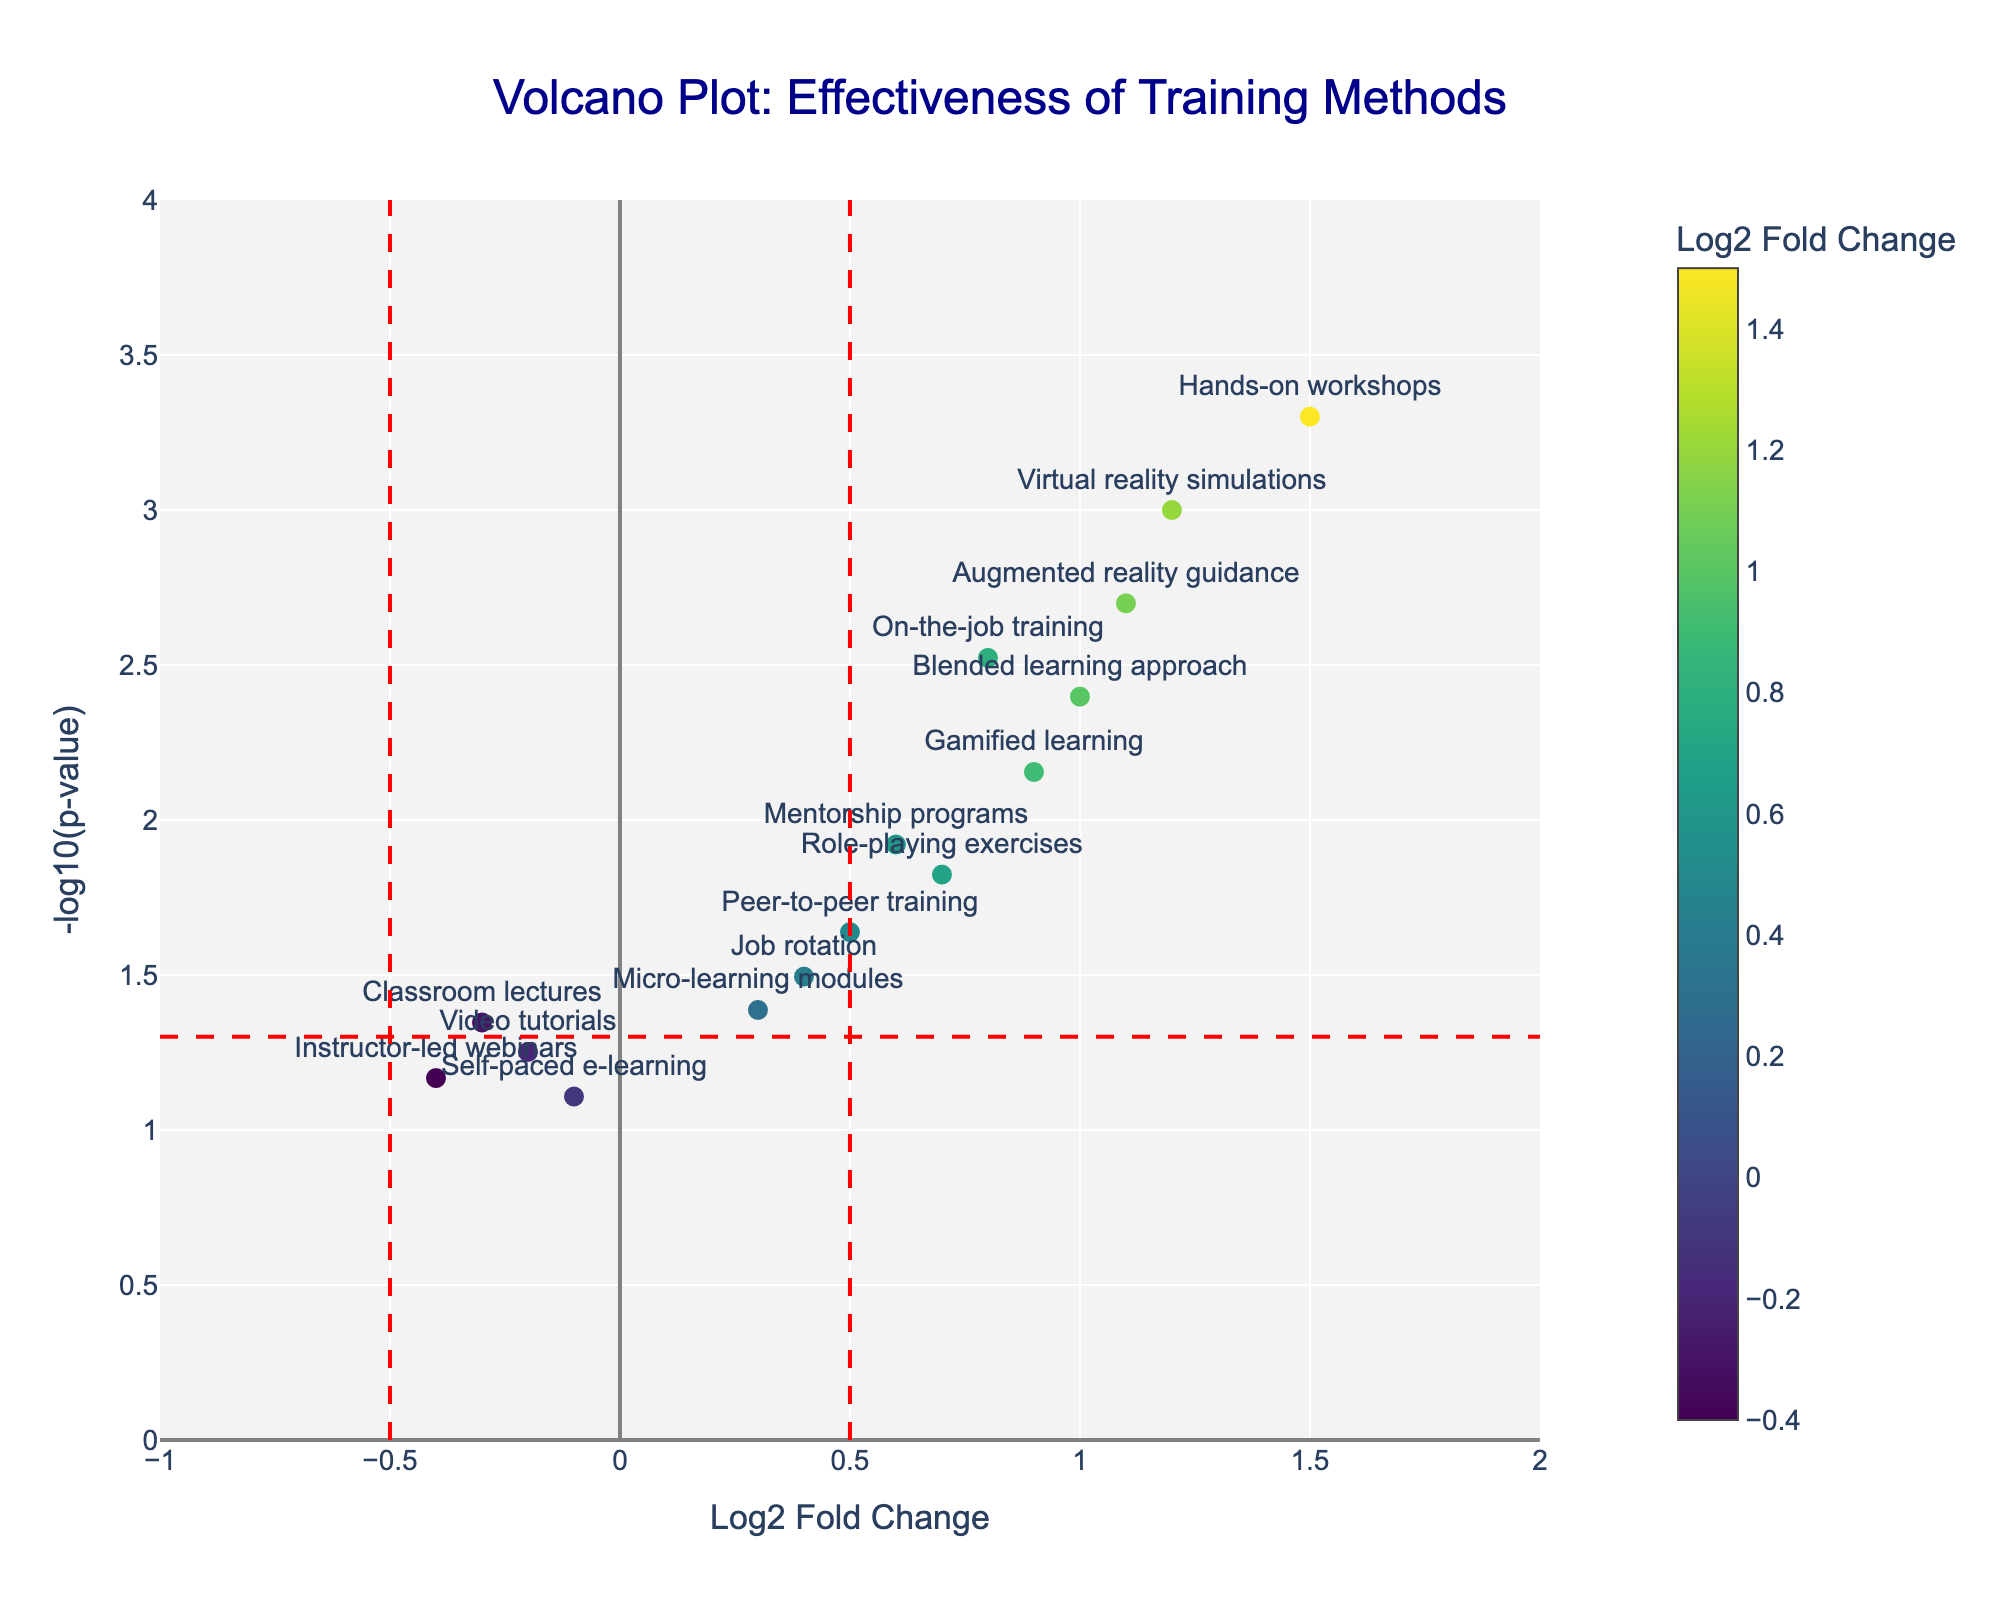How many training methods have a Log2 Fold Change greater than 1? To identify the number of training methods with a Log2 Fold Change greater than 1, look at the x-axis values and count the points that fall to the right of the x=1 line.
Answer: 4 Which training method has the highest Log2 Fold Change? Look for the data point located farthest to the right on the x-axis, this training method will have the highest Log2 Fold Change value.
Answer: Hands-on workshops What does the horizontal red dashed line represent in the plot? The horizontal red dashed line denotes a threshold in the y-axis and corresponds to -log10(p-value) = -log10(0.05), implying a p-value of 0.05.
Answer: p-value threshold How many training methods have p-values less than 0.05? Identify the number of points that are above the horizontal red dashed line (-log10(0.05)) on the y-axis, as these points represent the methods with p-values less than 0.05.
Answer: 10 Which training methods have negative Log2 Fold Change values? Look at the x-axis values and find points that fall to the left of the x=0 reference line; these points represent training methods with negative Log2 Fold Change values.
Answer: Classroom lectures, Self-paced e-learning, Video tutorials, Instructor-led webinars Which training method has the smallest (most negative) Log2 Fold Change and what is its p-value? Locate the point farthest to the left on the x-axis to identify the smallest Log2 Fold Change and note its p-value by checking its y-axis position.
Answer: Instructor-led webinars, 0.068 Are there any training methods with a Log2 Fold Change between -0.5 and 0.5 and a p-value less than 0.05? Examine the data points within the x-axis range -0.5 to 0.5 while also being above the horizontal dashed line indicating p-value < 0.05.
Answer: Job rotation, Micro-learning modules Which training method with a Log2 Fold Change greater than 1 also has one of the lowest p-values? Among data points with Log2 Fold Change greater than 1 (x-axis >1), identify the one with the highest y-axis value (lowest p-value).
Answer: Hands-on workshops Compare the effectiveness of "Virtual reality simulations" and "Blended learning approach" in terms of Log2 Fold Change and p-value. Locate the points for these two methods and compare their positions on both the x-axis (Log2 Fold Change) and y-axis (-log10(p-value)).
Answer: Virtual reality simulations: higher Log2 Fold Change and lower p-value 